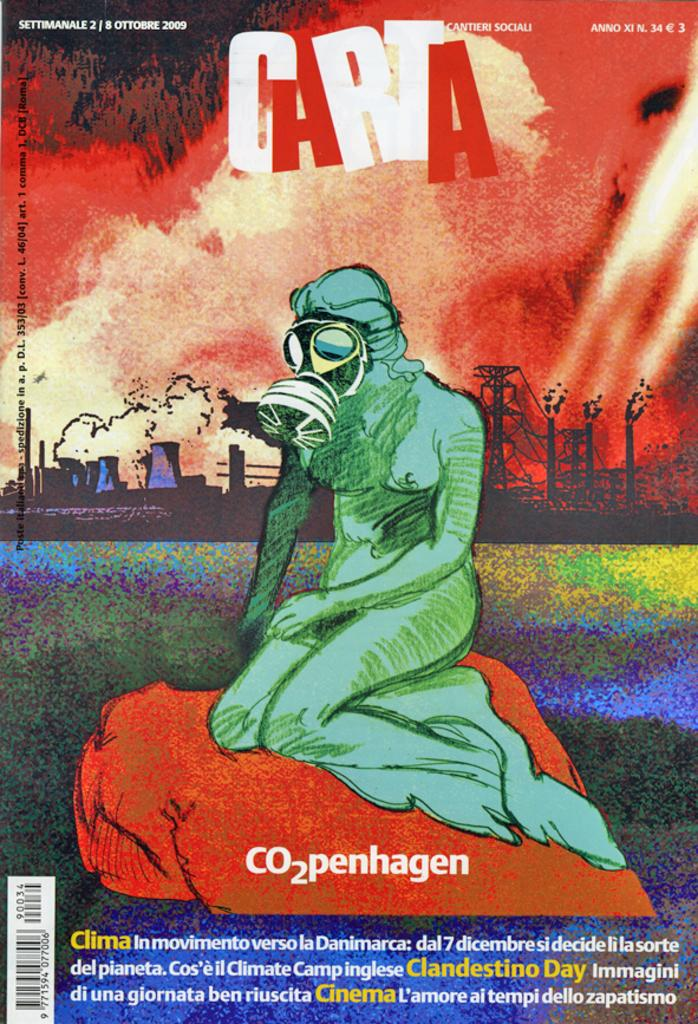<image>
Render a clear and concise summary of the photo. A book or magazine called Carta that says CO2penhagen. 